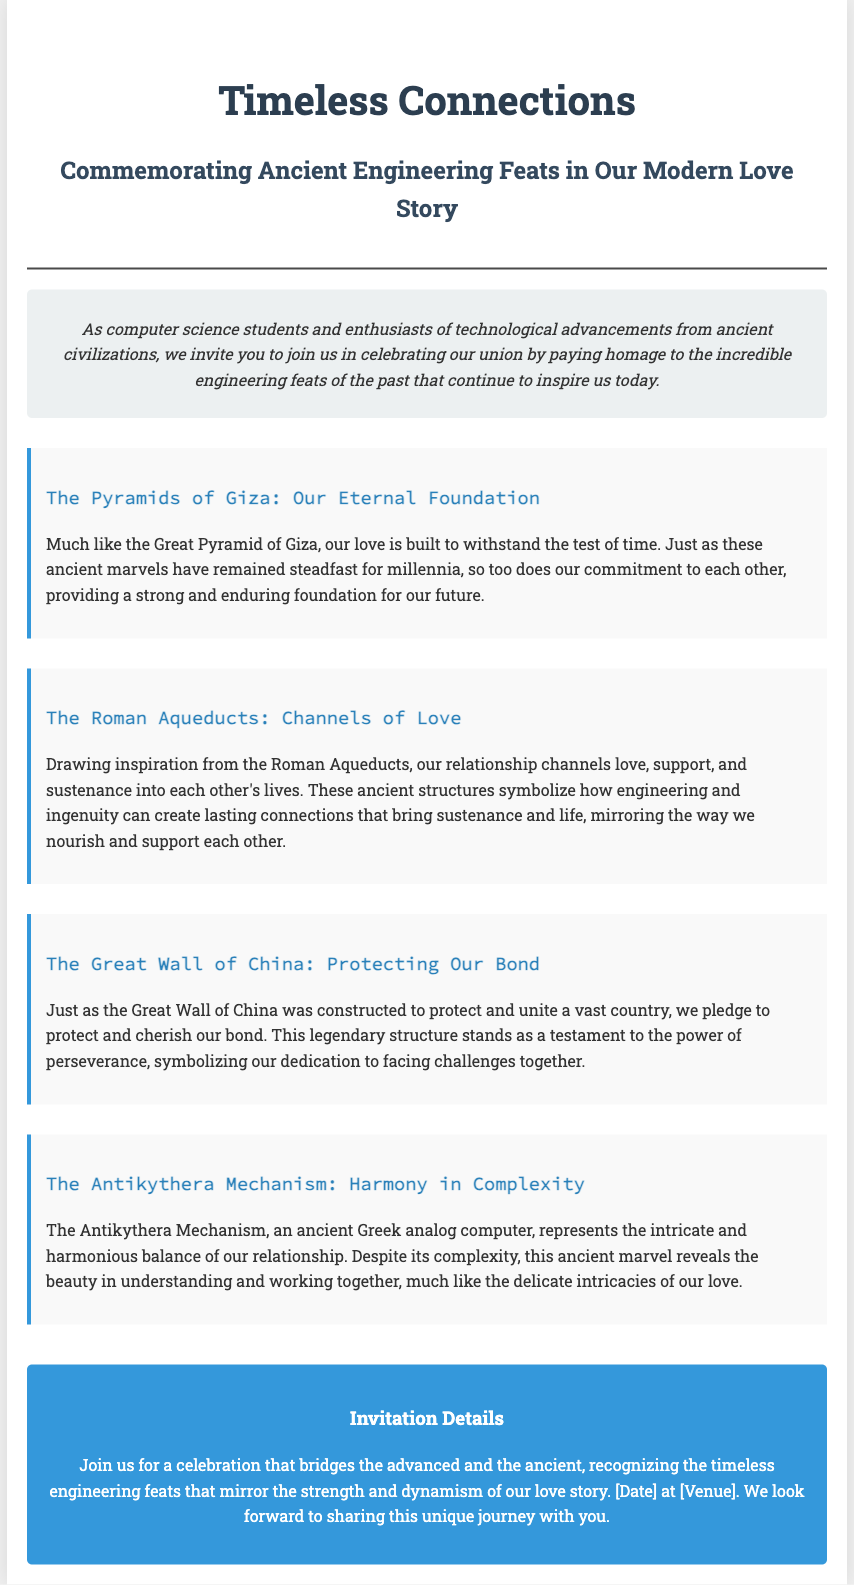what is the title of the wedding invitation? The title is stated prominently at the top of the invitation document.
Answer: Timeless Connections who are the main subjects of the invitation? The invitation refers to the authors and their connection as computer science students and enthusiasts.
Answer: computer science students what ancient engineering feat is mentioned as a foundation for love? The text relates a specific ancient structure as a metaphor for the foundation of their love.
Answer: The Pyramids of Giza which ancient structure symbolizes the couple’s commitment to protect their bond? The invitation mentions a specific ancient structure representative of protection and unity.
Answer: The Great Wall of China what does the Antikythera Mechanism represent in the context of the invitation? The document explains the significance of the Antikythera Mechanism as a metaphor relating to the relationship.
Answer: Harmony in Complexity what is the date of the wedding celebration? The invitation includes a placeholder for the date but doesn't specify it in the text.
Answer: [Date] where is the wedding venue mentioned in the invitation? The document specifies a placeholder for the venue but does not provide a specific name.
Answer: [Venue] how is love symbolized through the Roman Aqueducts in the invitation? The invitation describes the role of this ancient engineering feat in conveying support and sustenance in the couple’s lives.
Answer: Channels of Love 